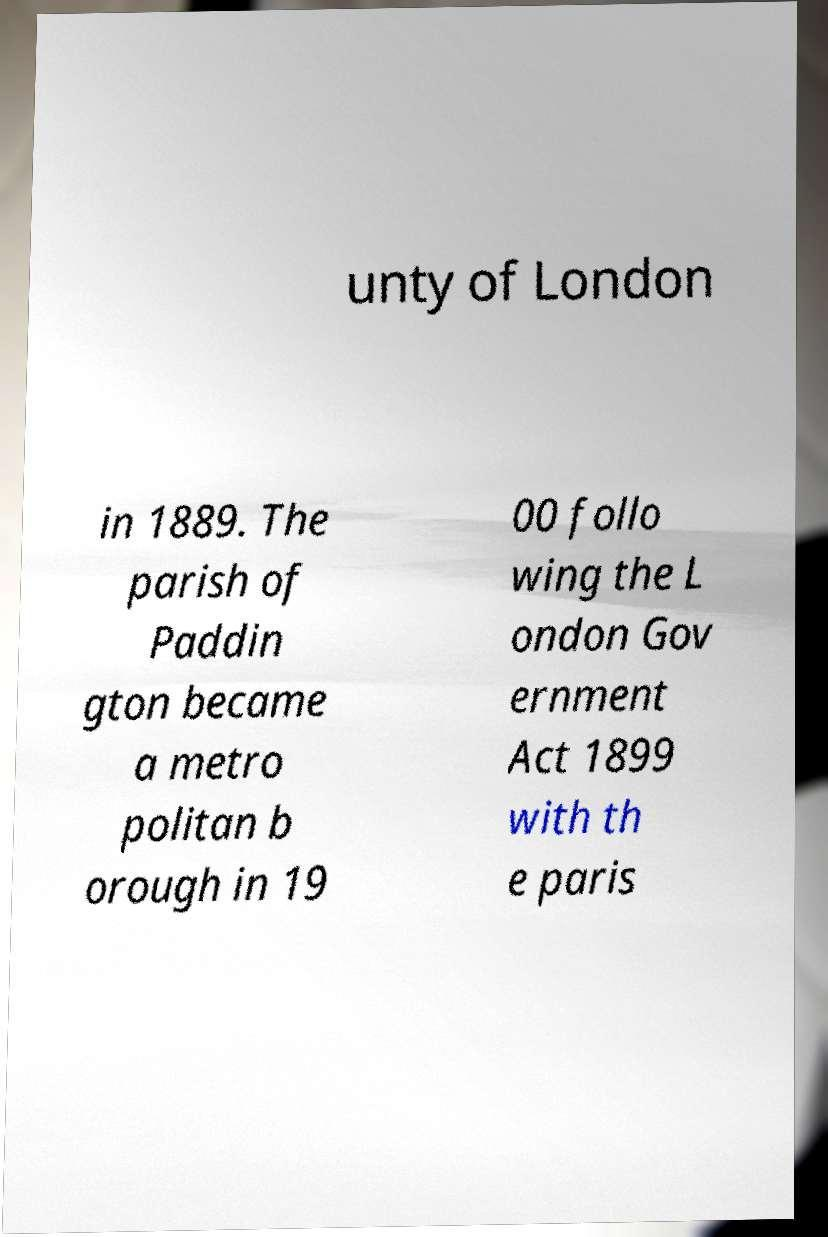What messages or text are displayed in this image? I need them in a readable, typed format. unty of London in 1889. The parish of Paddin gton became a metro politan b orough in 19 00 follo wing the L ondon Gov ernment Act 1899 with th e paris 